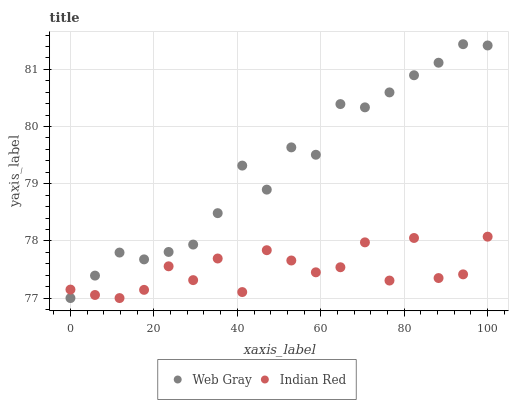Does Indian Red have the minimum area under the curve?
Answer yes or no. Yes. Does Web Gray have the maximum area under the curve?
Answer yes or no. Yes. Does Indian Red have the maximum area under the curve?
Answer yes or no. No. Is Web Gray the smoothest?
Answer yes or no. Yes. Is Indian Red the roughest?
Answer yes or no. Yes. Is Indian Red the smoothest?
Answer yes or no. No. Does Web Gray have the lowest value?
Answer yes or no. Yes. Does Web Gray have the highest value?
Answer yes or no. Yes. Does Indian Red have the highest value?
Answer yes or no. No. Does Web Gray intersect Indian Red?
Answer yes or no. Yes. Is Web Gray less than Indian Red?
Answer yes or no. No. Is Web Gray greater than Indian Red?
Answer yes or no. No. 